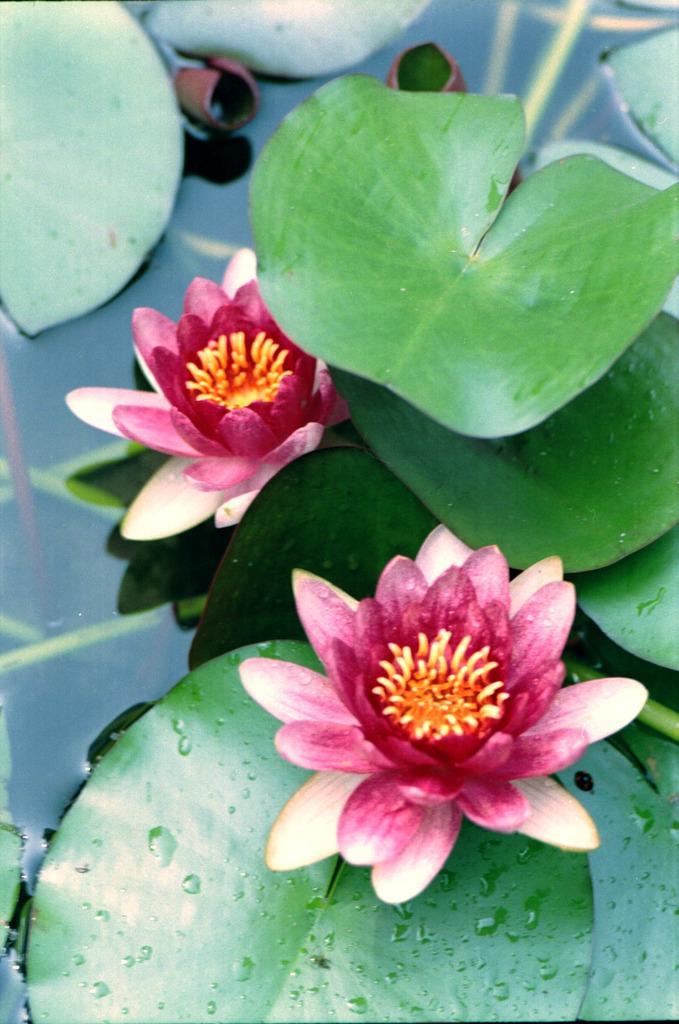Could you give a brief overview of what you see in this image? In this picture I can see that there are some lotus flowers in a pond and there are some leaves. 